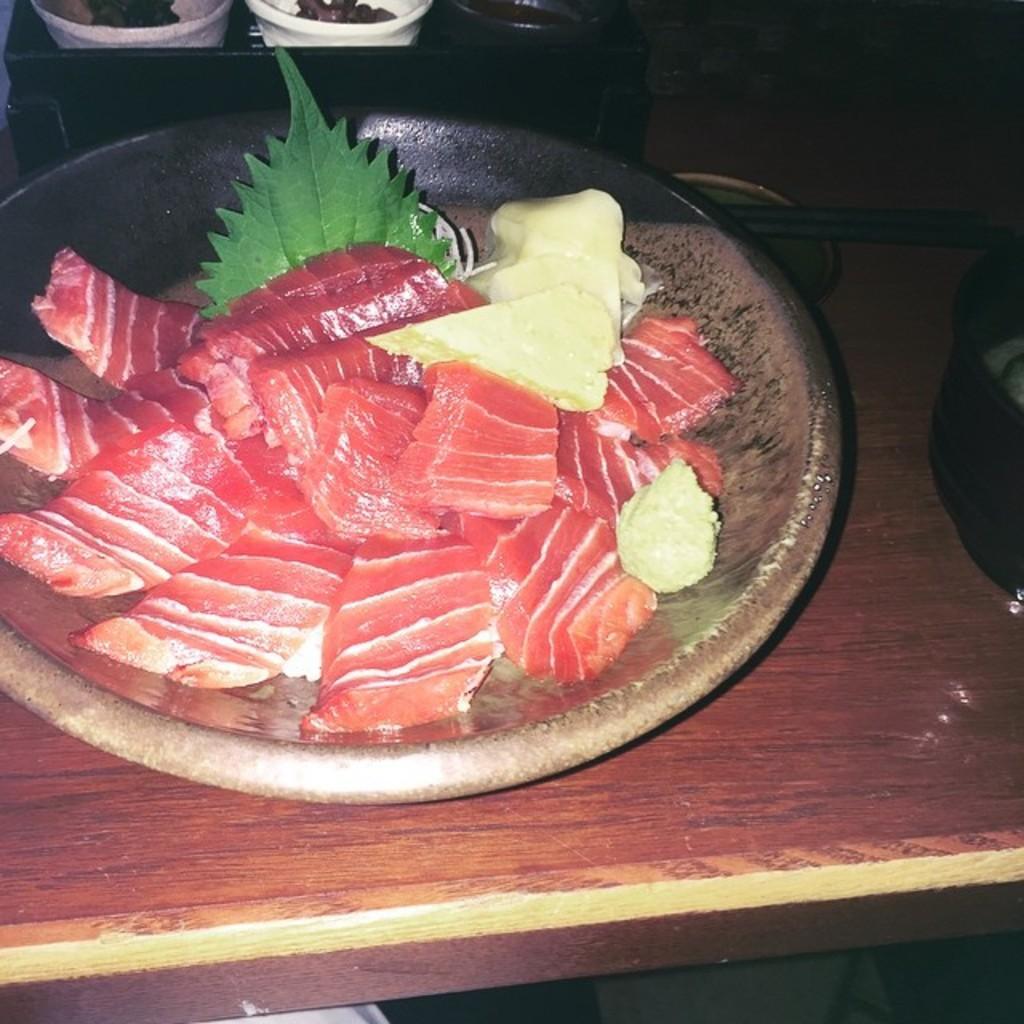Describe this image in one or two sentences. In this image I can see the brown colored table and on the table I can see a bowl which is brown in color. In the bowl I can see few food items which are white, red, cream and brown in color and I can see a leaf which is green in color. I can see few other bowls which are white in color and few other black colored objects on the table. 